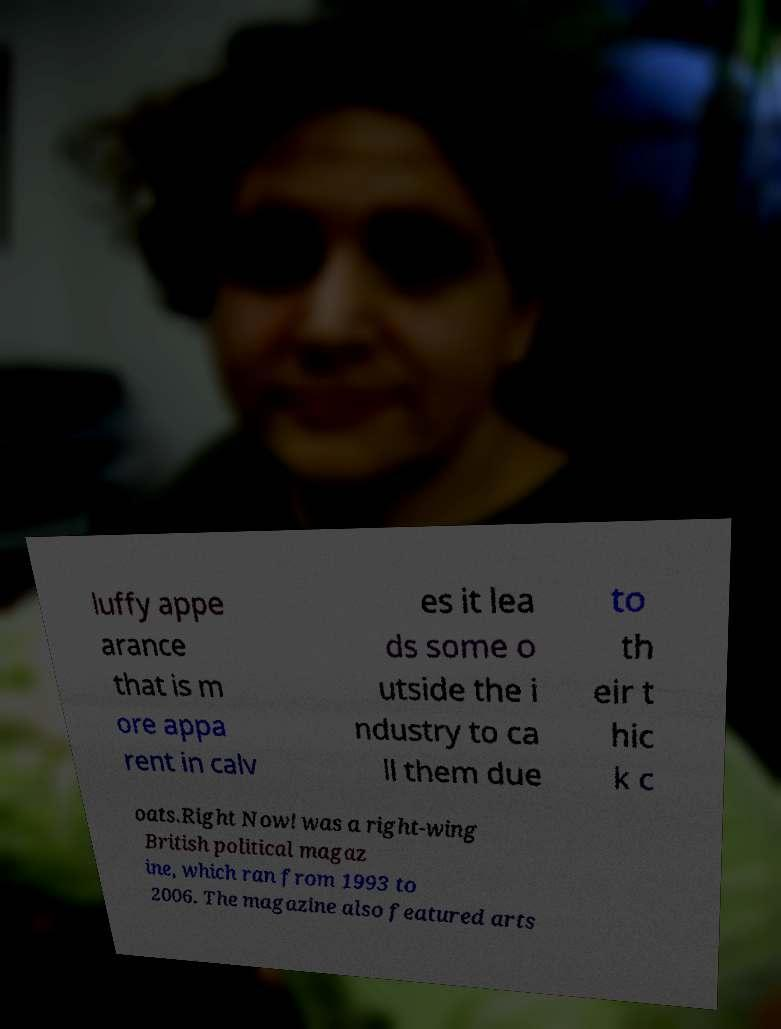Can you read and provide the text displayed in the image?This photo seems to have some interesting text. Can you extract and type it out for me? luffy appe arance that is m ore appa rent in calv es it lea ds some o utside the i ndustry to ca ll them due to th eir t hic k c oats.Right Now! was a right-wing British political magaz ine, which ran from 1993 to 2006. The magazine also featured arts 